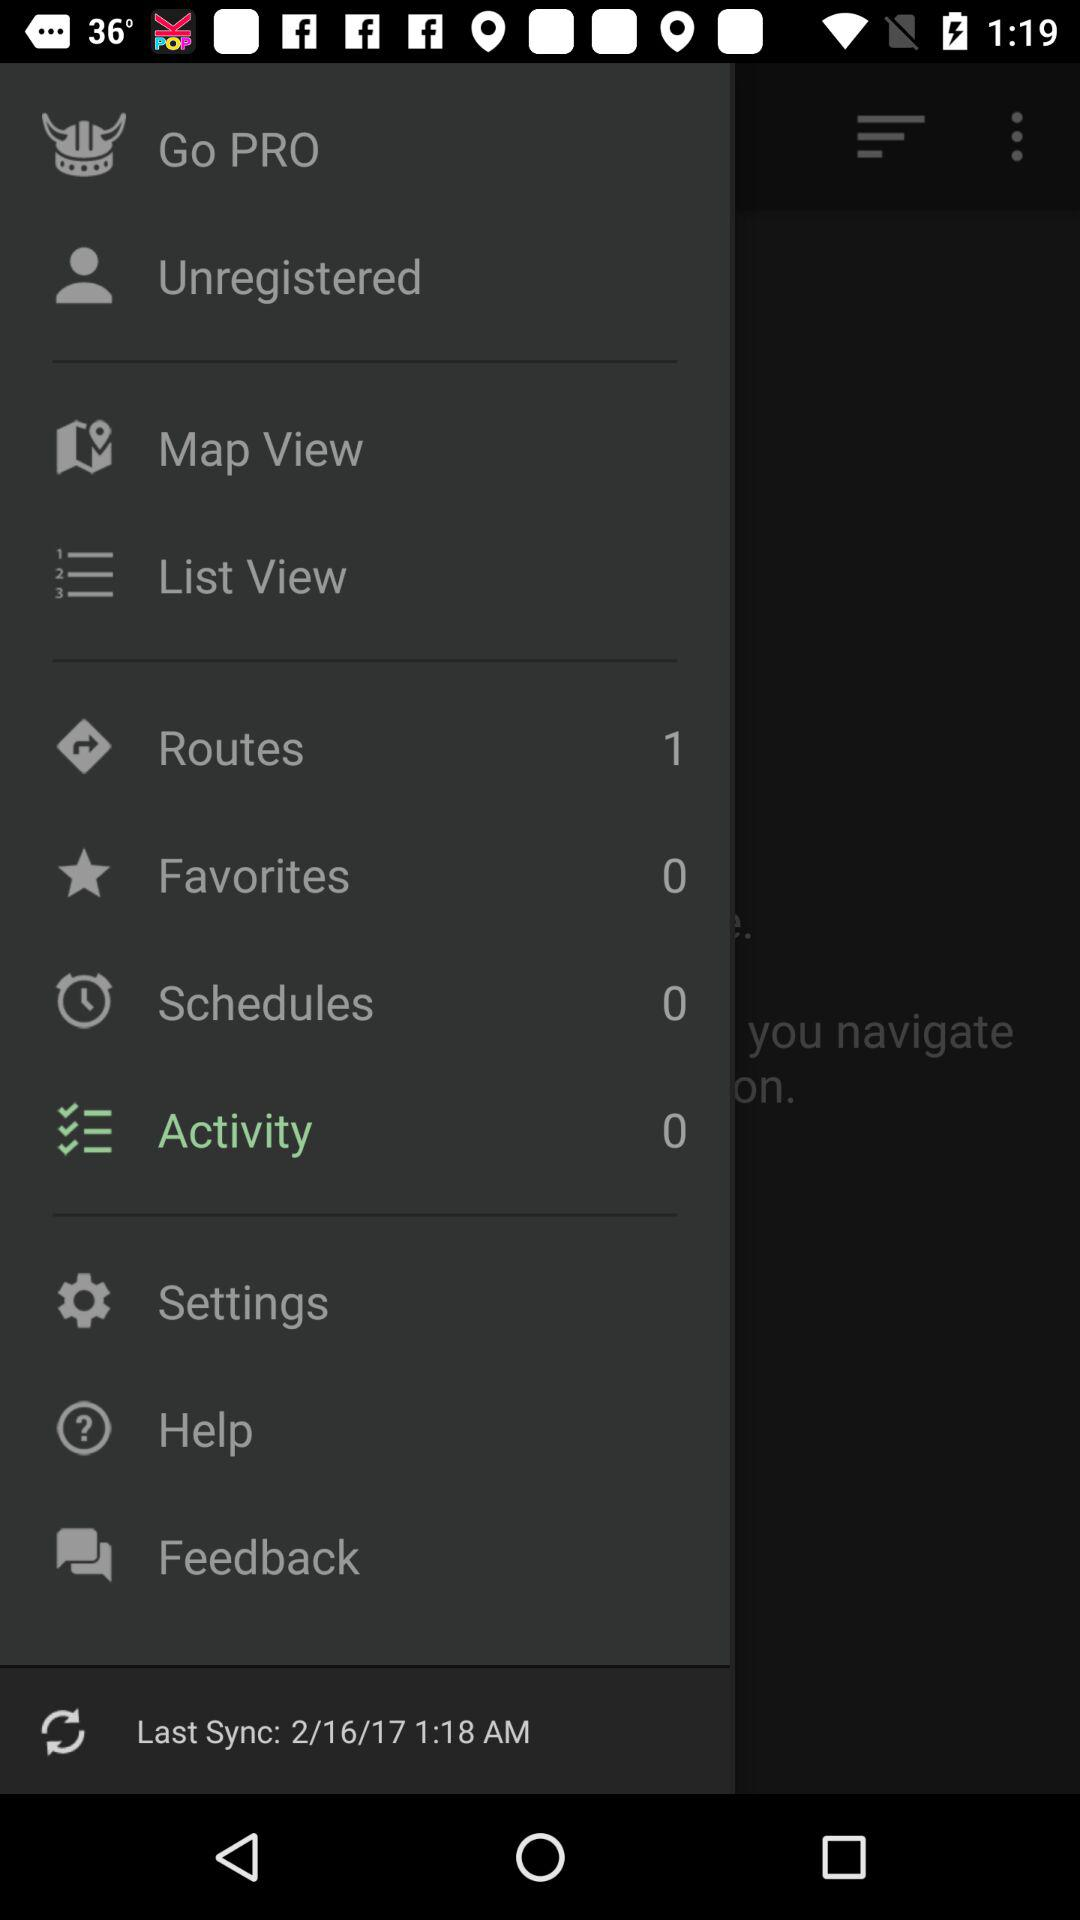How many items are there in "Routes"? There is 1 item in "Routes". 